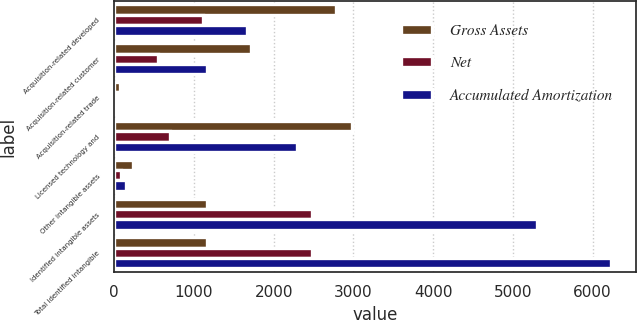Convert chart. <chart><loc_0><loc_0><loc_500><loc_500><stacked_bar_chart><ecel><fcel>Acquisition-related developed<fcel>Acquisition-related customer<fcel>Acquisition-related trade<fcel>Licensed technology and<fcel>Other intangible assets<fcel>Identified intangible assets<fcel>Total identified intangible<nl><fcel>Gross Assets<fcel>2778<fcel>1712<fcel>68<fcel>2986<fcel>238<fcel>1161<fcel>1161<nl><fcel>Net<fcel>1116<fcel>551<fcel>33<fcel>699<fcel>86<fcel>2485<fcel>2485<nl><fcel>Accumulated Amortization<fcel>1662<fcel>1161<fcel>35<fcel>2287<fcel>152<fcel>5297<fcel>6235<nl></chart> 